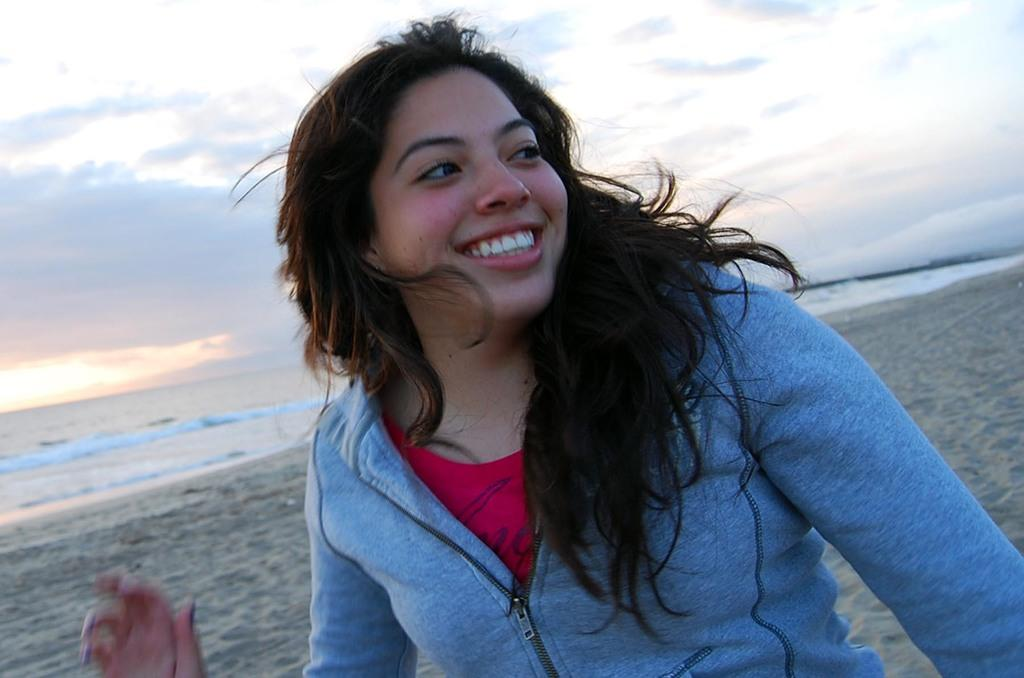Who is present in the image? There is a woman in the image. What is the woman's facial expression? The woman is smiling. What type of terrain is visible in the image? There is sand in the image. What can be seen in the water? Waves are visible in the water. How would you describe the sky in the image? The sky is cloudy. What type of drain is visible in the image? There is no drain present in the image. Can you see any signs of a fight happening in the image? There is no indication of a fight in the image. 